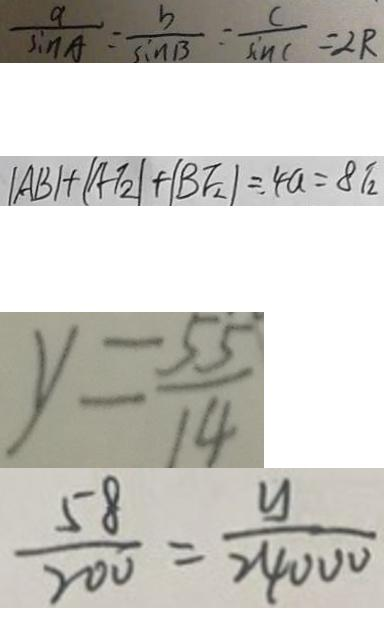<formula> <loc_0><loc_0><loc_500><loc_500>\frac { a } { \sin A } = \frac { b } { \sin B } = \frac { c } { \sin C } = 2 R 
 \vert A B \vert + \vert A T _ { 2 } \vert + \vert B F _ { 2 } \vert = 4 a = 8 T _ { 2 } 
 y = \frac { 5 5 } { 1 4 } 
 \frac { 5 8 } { 2 0 0 } = \frac { y } { 2 4 0 0 0 }</formula> 